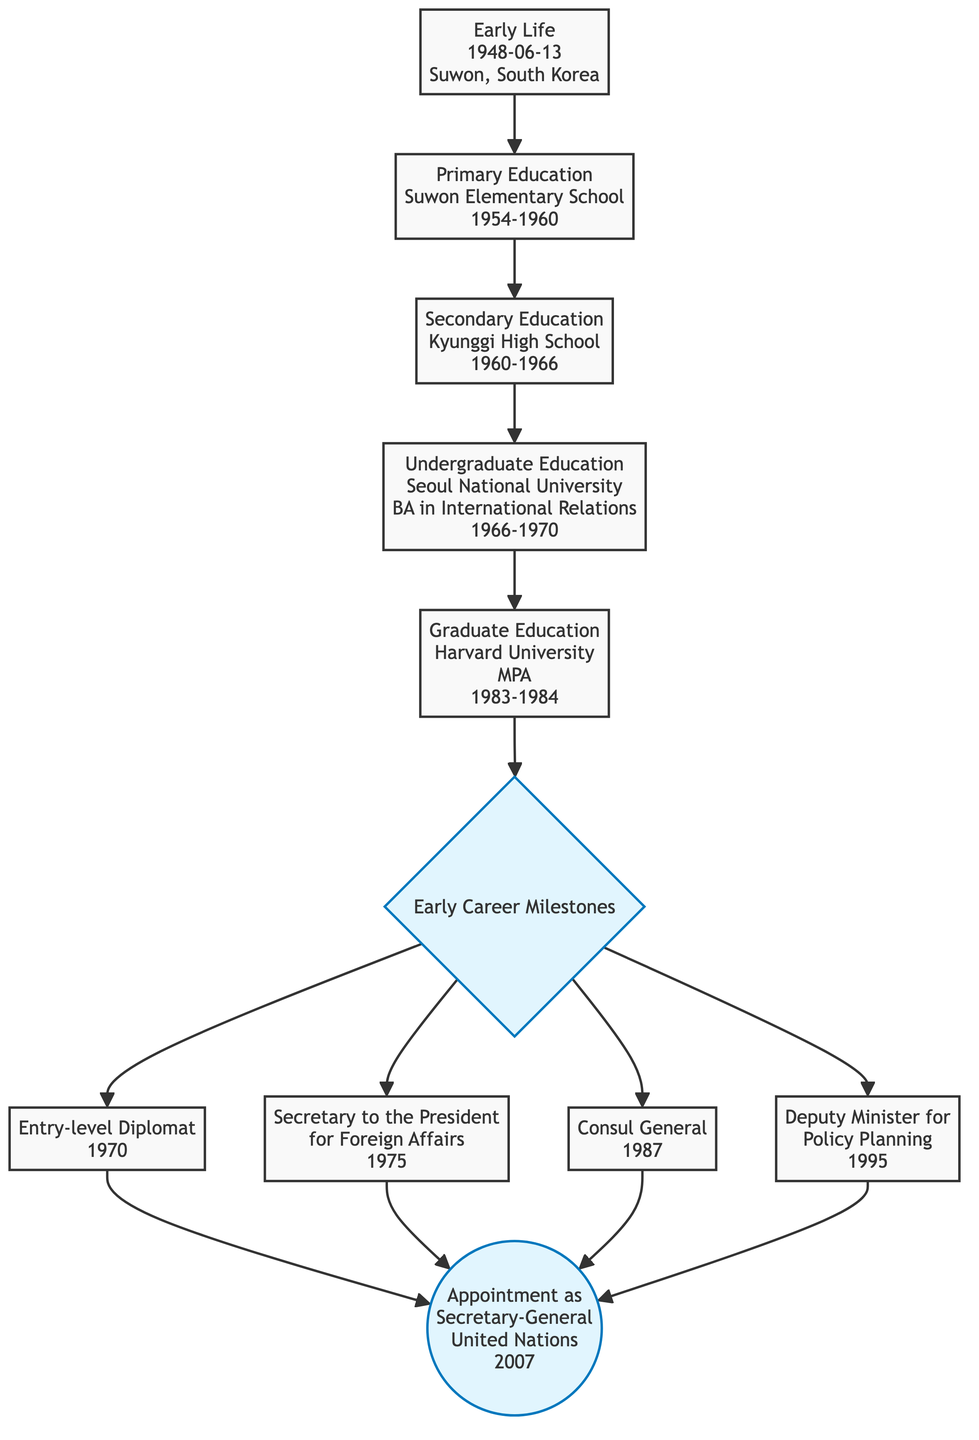What is the date of birth of the former Secretary-General? The diagram clearly denotes the former Secretary-General's date of birth at the Early Life block, which states "1948-06-13."
Answer: 1948-06-13 Where did the former Secretary-General attend primary school? According to the diagram, the Primary Education block provides the name of the school attended, which is "Suwon Elementary School."
Answer: Suwon Elementary School What was the major studied during undergraduate education? The diagram indicates in the Undergraduate Education block that the major was "Bachelor of Arts in International Relations."
Answer: Bachelor of Arts in International Relations In what year was the former Secretary-General appointed as Secretary-General? The diagram concludes with the Appointment as Secretary-General block, which shows the year of appointment as "2007."
Answer: 2007 What two achievements did the former Secretary-General have in undergraduate education? In the Undergraduate Education block, two achievements are listed: "Graduated summa cum laude" and "Active member of the Model United Nations."
Answer: Graduated summa cum laude, Active member of the Model United Nations How many years did the former Secretary-General attend secondary school? The Secondary Education block states that the years attended at Kyunggi High School were from 1960 to 1966, which calculates to 6 years.
Answer: 6 years What milestone followed the position of Consul General in the former Secretary-General's early career? The diagram lists the early career milestones in a sequence, showing that the Deputy Minister for Policy Planning position follows the Consul General role in 1987, detailing that the Deputy Minister position came after it.
Answer: Deputy Minister for Policy Planning Which university did the former Secretary-General attend for graduate education? The Graduate Education block specifies that the university attended was "Harvard University, John F. Kennedy School of Government."
Answer: Harvard University, John F. Kennedy School of Government What role did the former Secretary-General hold in 1975? According to the Early Career Milestones block, the individual held the role of "Secretary to the President for Foreign Affairs" in 1975.
Answer: Secretary to the President for Foreign Affairs 